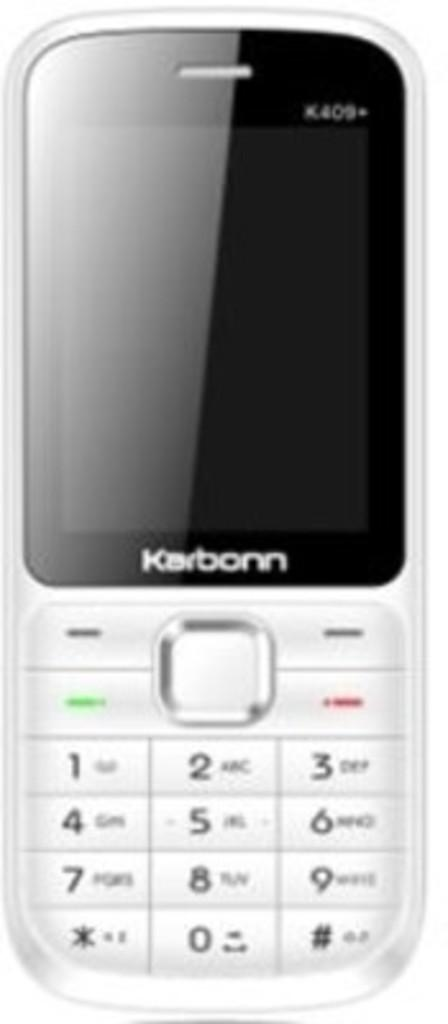<image>
Create a compact narrative representing the image presented. a phone that has the word Karbonn on it 